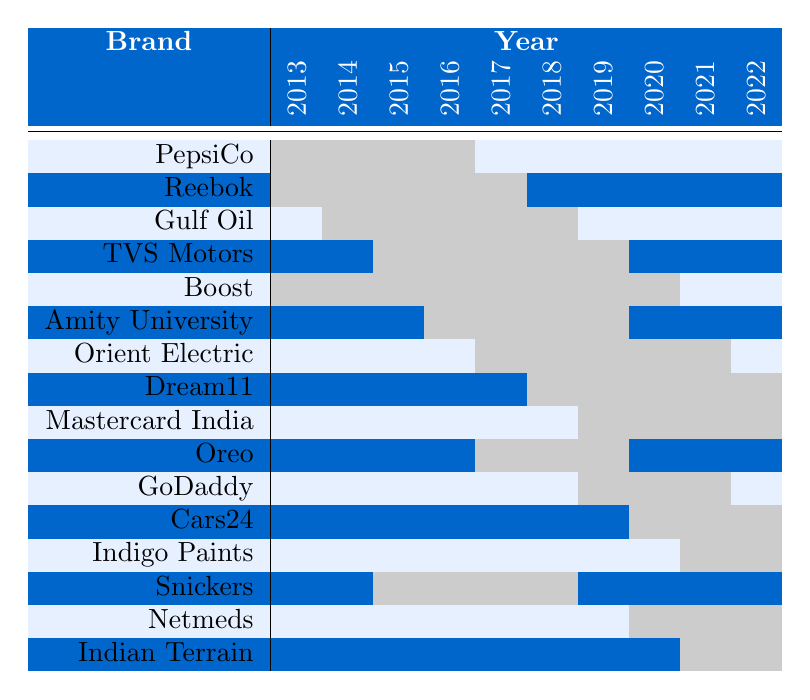What brands did M.S. Dhoni endorse in 2015? In the table, I check the row for each brand in the year 2015. The brands with endorsements in 2015 are Reebok, Gulf Oil, Boost, Amity University, and Dream11.
Answer: Reebok, Gulf Oil, Boost, Amity University, Dream11 How many brands did M.S. Dhoni endorse in 2017? In the year 2017, I need to look at the row for each brand. The brands endorsed are PepsiCo, Reebok, Gulf Oil, TVS Motors, Boost, Amity University, and Indian Terrain, resulting in a total of 7 brands.
Answer: 7 Did M.S. Dhoni continue endorsing Reebok in 2018? I can see from the table that Reebok is marked for 2014 and not for 2018, which indicates that he did not endorse Reebok in 2018.
Answer: No Which years did M.S. Dhoni endorse the brand Dream11? I look at the row for Dream11 and see that it is endorsed in 2019, 2020, 2021, and 2022 according to the table.
Answer: 2019, 2020, 2021, 2022 What is the total number of different brands endorsed by M.S. Dhoni over the decade? I can count the unique brands listed: there are 15 different brands in total according to the brand names provided in the table.
Answer: 15 Which brand had the longest period of endorsement uninterrupted over the years? By reviewing the rows, the brand Boost had endorsements from 2013 to 2018, making it the longest uninterrupted period.
Answer: Boost In how many years did M.S. Dhoni endorse Gulf Oil? Checking the row for Gulf Oil, it shows that it appeared in 2014, 2015, 2016, and 2017, which is a total of 4 years.
Answer: 4 Which brand did Dhoni start endorsing in 2019? Looking at the table, in 2019, M.S. Dhoni began endorsing Dream11, as it is marked for that year and not indicated in the previous years.
Answer: Dream11 What was the trend for brand endorsements from 2013 to 2022? I analyze the table and notice that M.S. Dhoni had a decreasing frequency of endorsements over the years, with diverse brands at the start and fewer in 2022.
Answer: Decreasing trend Is it true that M.S. Dhoni never endorsed Indian Terrain before 2022? Observing the table, I find that Indian Terrain is endorsed only in 2022 and not in any prior years, thus confirming the statement.
Answer: True How many brands were endorsed at least for 3 consecutive years? By examining the table, I count it; only Boost and Gulf Oil were endorsed for 3 consecutive years (2014-2016 and 2015-2017 respectively).
Answer: 2 